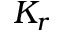<formula> <loc_0><loc_0><loc_500><loc_500>K _ { r }</formula> 